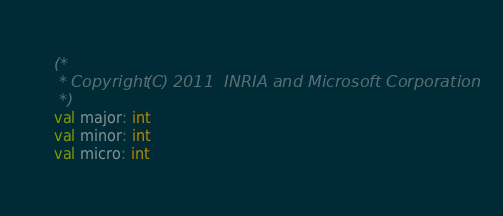Convert code to text. <code><loc_0><loc_0><loc_500><loc_500><_OCaml_>(*
 * Copyright (C) 2011  INRIA and Microsoft Corporation
 *)
val major: int
val minor: int
val micro: int
</code> 